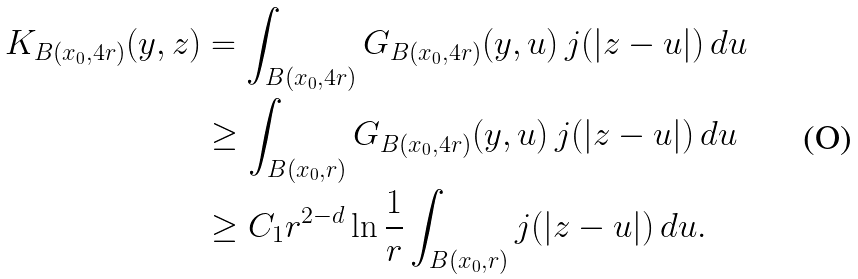Convert formula to latex. <formula><loc_0><loc_0><loc_500><loc_500>K _ { B ( x _ { 0 } , 4 r ) } ( y , z ) & = \int _ { B ( x _ { 0 } , 4 r ) } G _ { B ( x _ { 0 } , 4 r ) } ( y , u ) \, j ( | z - u | ) \, d u \\ & \geq \int _ { B ( x _ { 0 } , r ) } G _ { B ( x _ { 0 } , 4 r ) } ( y , u ) \, j ( | z - u | ) \, d u \\ & \geq C _ { 1 } r ^ { 2 - d } \ln \frac { 1 } { r } \int _ { B ( x _ { 0 } , r ) } j ( | z - u | ) \, d u .</formula> 